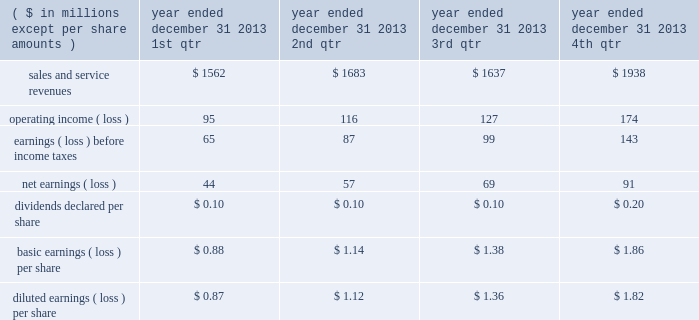"three factor formula" ) .
The consolidated financial statements include northrop grumman management and support services allocations totaling $ 32 million for the year ended december 31 , 2011 .
Shared services and infrastructure costs - this category includes costs for functions such as information technology support , systems maintenance , telecommunications , procurement and other shared services while hii was a subsidiary of northrop grumman .
These costs were generally allocated to the company using the three factor formula or based on usage .
The consolidated financial statements reflect shared services and infrastructure costs allocations totaling $ 80 million for the year ended december 31 , 2011 .
Northrop grumman-provided benefits - this category includes costs for group medical , dental and vision insurance , 401 ( k ) savings plan , pension and postretirement benefits , incentive compensation and other benefits .
These costs were generally allocated to the company based on specific identification of the benefits provided to company employees participating in these benefit plans .
The consolidated financial statements include northrop grumman- provided benefits allocations totaling $ 169 million for the year ended december 31 , 2011 .
Management believes that the methods of allocating these costs are reasonable , consistent with past practices , and in conformity with cost allocation requirements of cas or the far .
Related party sales and cost of sales prior to the spin-off , hii purchased and sold certain products and services from and to other northrop grumman entities .
Purchases of products and services from these affiliated entities , which were recorded at cost , were $ 44 million for the year ended december 31 , 2011 .
Sales of products and services to these entities were $ 1 million for the year ended december 31 , 2011 .
Former parent's equity in unit transactions between hii and northrop grumman prior to the spin-off have been included in the consolidated financial statements and were effectively settled for cash at the time the transaction was recorded .
The net effect of the settlement of these transactions is reflected as former parent's equity in unit in the consolidated statement of changes in equity .
21 .
Unaudited selected quarterly data unaudited quarterly financial results for the years ended december 31 , 2013 and 2012 , are set forth in the tables: .

What is the total operating income for the fiscal year of 2013? 
Computations: (((95 + 116) + 127) + 174)
Answer: 512.0. 